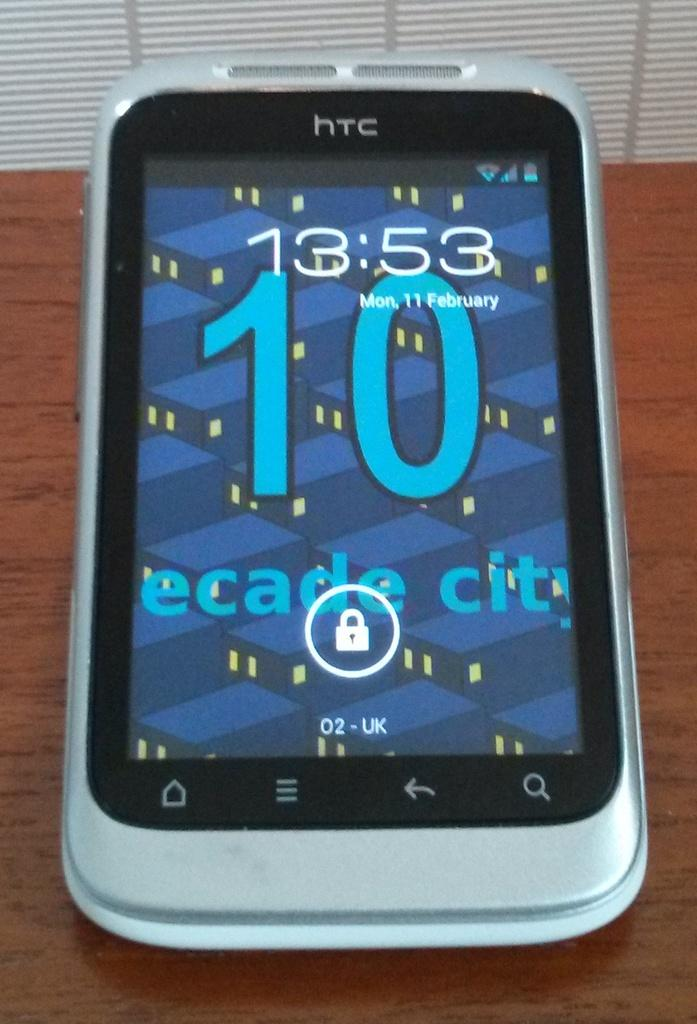<image>
Give a short and clear explanation of the subsequent image. An HTC phone is on the lock screen and the time reads 13:53. 